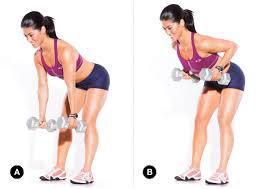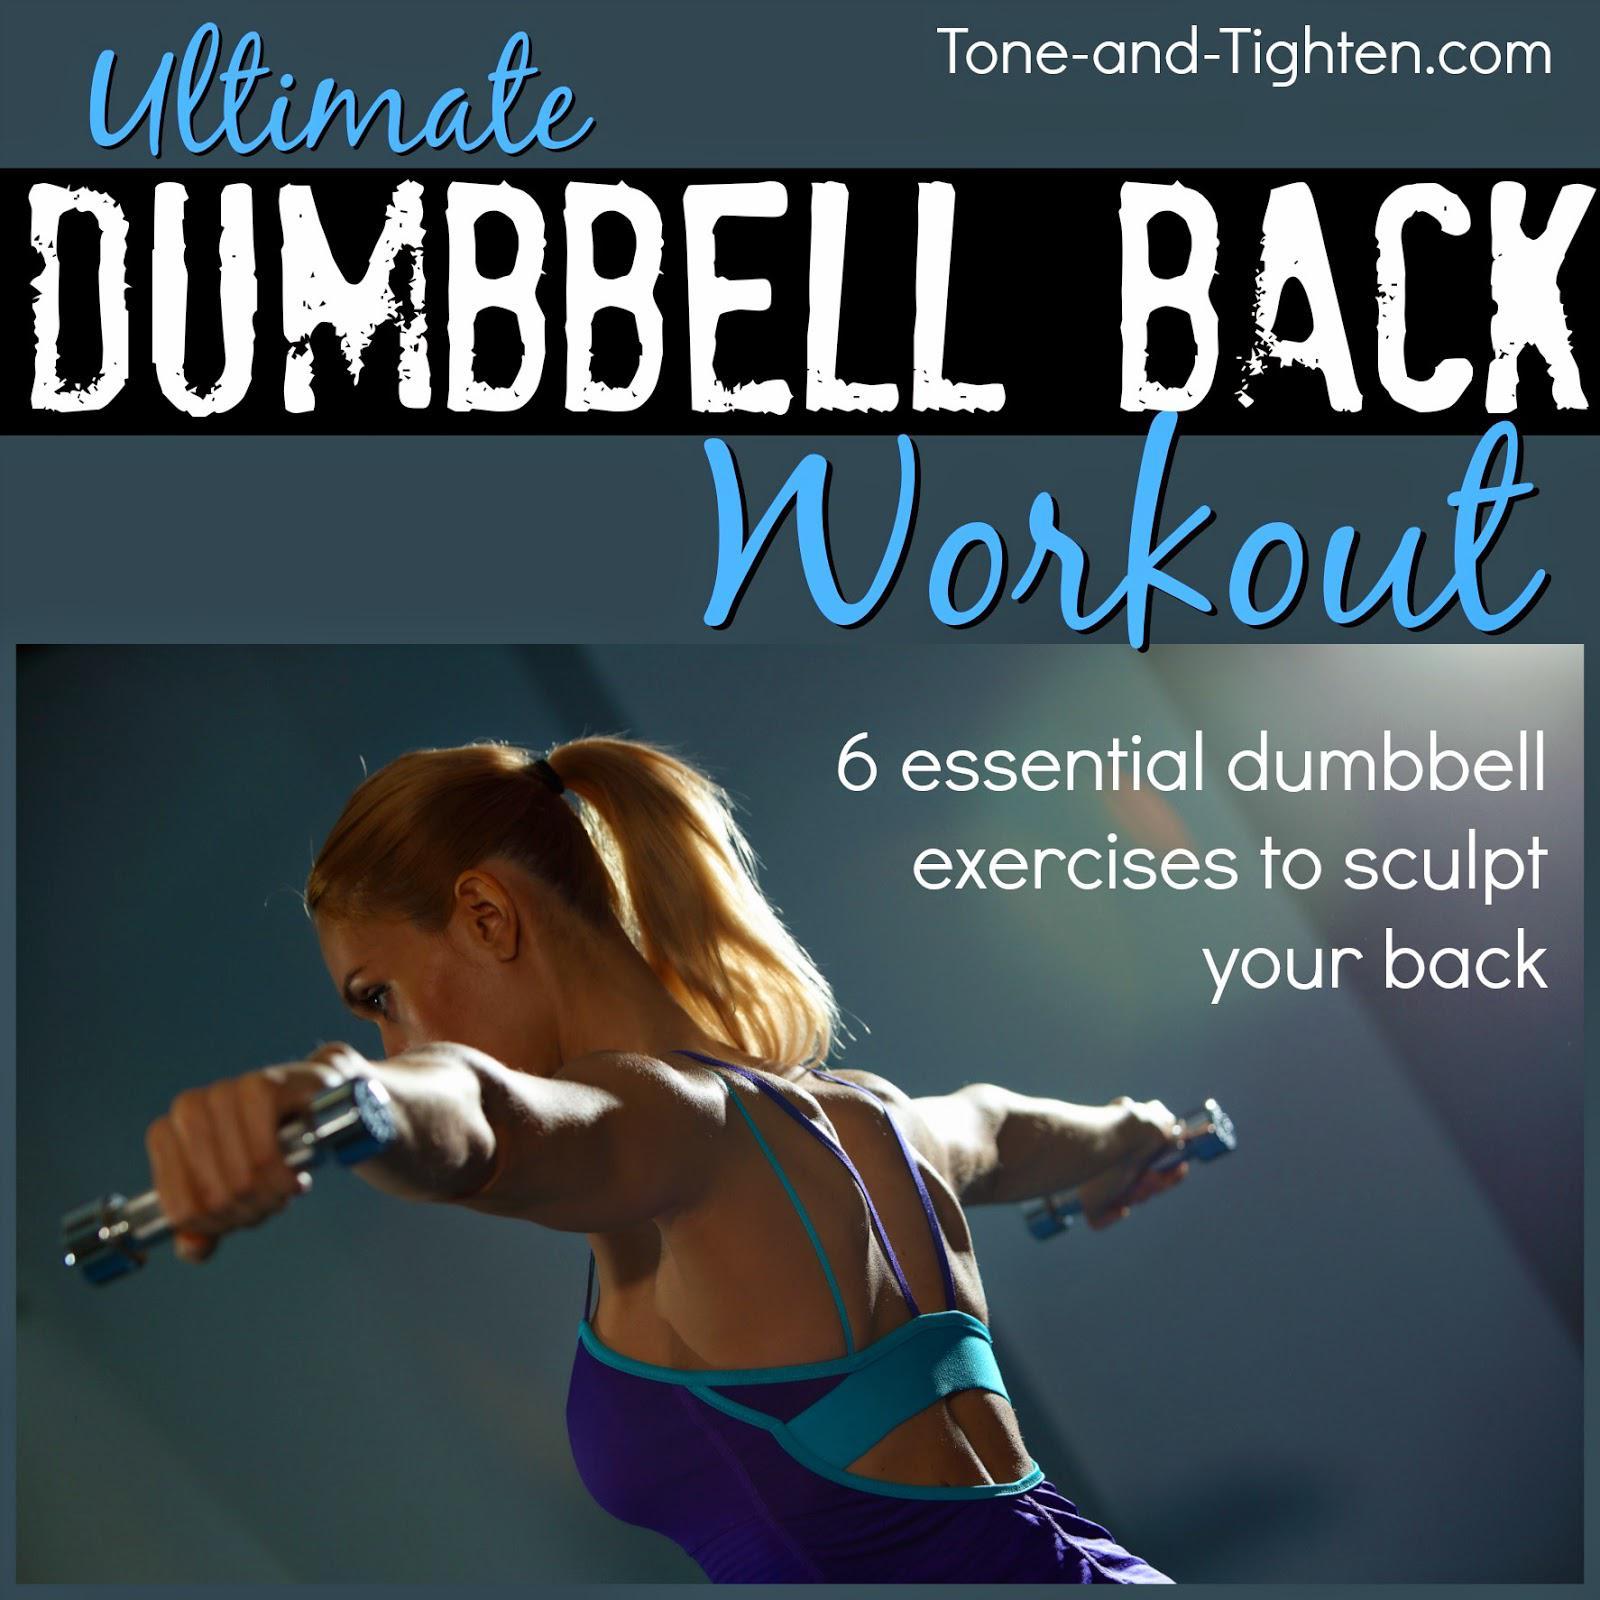The first image is the image on the left, the second image is the image on the right. Evaluate the accuracy of this statement regarding the images: "There are shirtless men lifting weights". Is it true? Answer yes or no. No. 